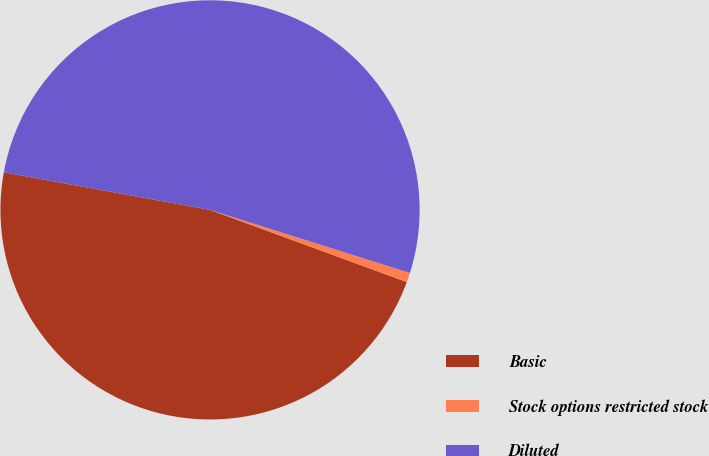<chart> <loc_0><loc_0><loc_500><loc_500><pie_chart><fcel>Basic<fcel>Stock options restricted stock<fcel>Diluted<nl><fcel>47.27%<fcel>0.73%<fcel>52.0%<nl></chart> 